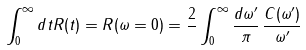Convert formula to latex. <formula><loc_0><loc_0><loc_500><loc_500>\int _ { 0 } ^ { \infty } d t R ( t ) = R ( \omega = 0 ) = \frac { 2 } { } \int _ { 0 } ^ { \infty } \frac { d \omega ^ { \prime } } { \pi } \, \frac { C ( \omega ^ { \prime } ) } { \omega ^ { \prime } }</formula> 